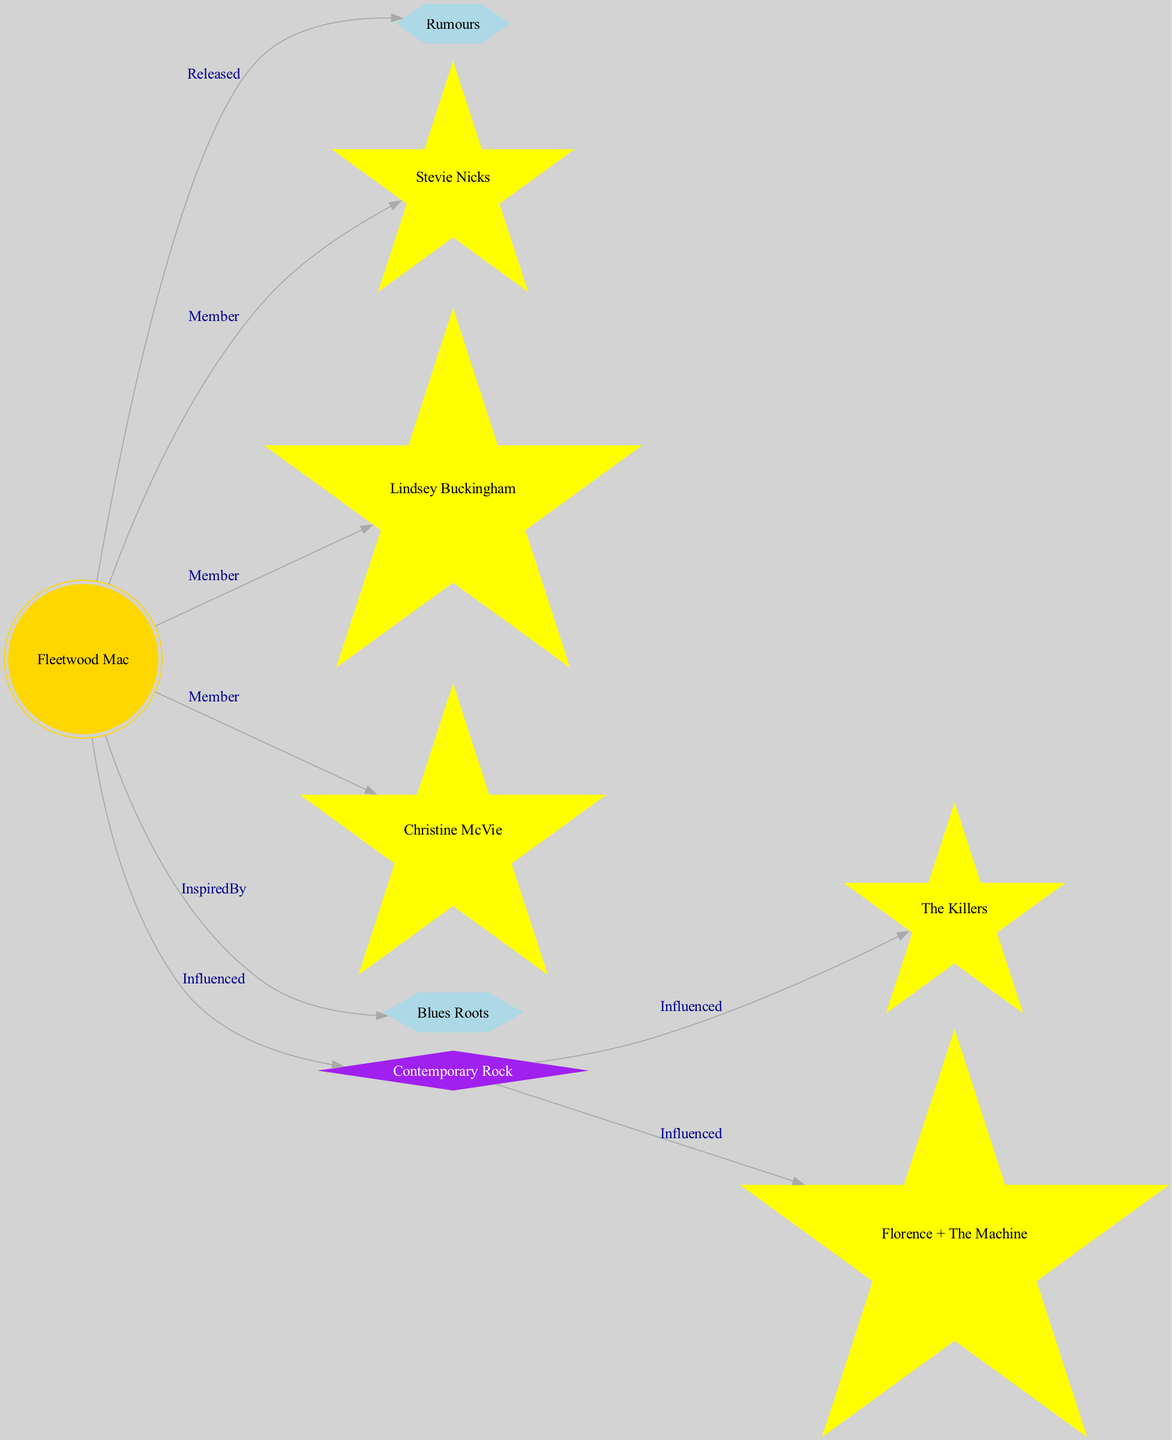What is the central node in the diagram? The diagram presents Fleetwood Mac as the central node, indicated by its direct connections to various other nodes. It's positioned at the center of the graph, emphasizing its importance in the influence mapping.
Answer: Fleetwood Mac How many star nodes are present in the diagram? By reviewing the node types, there are three star nodes: Stevie Nicks, Lindsey Buckingham, and Christine McVie. Counting these gives a total of three star nodes.
Answer: 3 What is the label of the cluster associated with Fleetwood Mac's most influential album? The cluster associated with Fleetwood Mac's most influential album is labeled "Rumours." This connection is indicated directly in the edge originating from the Fleetwood Mac node.
Answer: Rumours Which artist is connected as a member to Fleetwood Mac? The diagram shows connections from Fleetwood Mac to several members, including Stevie Nicks, Lindsey Buckingham, and Christine McVie. Any of these names can be a valid answer, but "Stevie Nicks" is commonly recognized.
Answer: Stevie Nicks What type of influence does Contemporary Rock have on The Killers? Within the diagram, the Contemporary Rock node directly influences The Killers, establishing a connection indicating that The Killers' sound has been shaped by Fleetwood Mac's music, as shown by the edge labeled "Influenced."
Answer: Influenced 